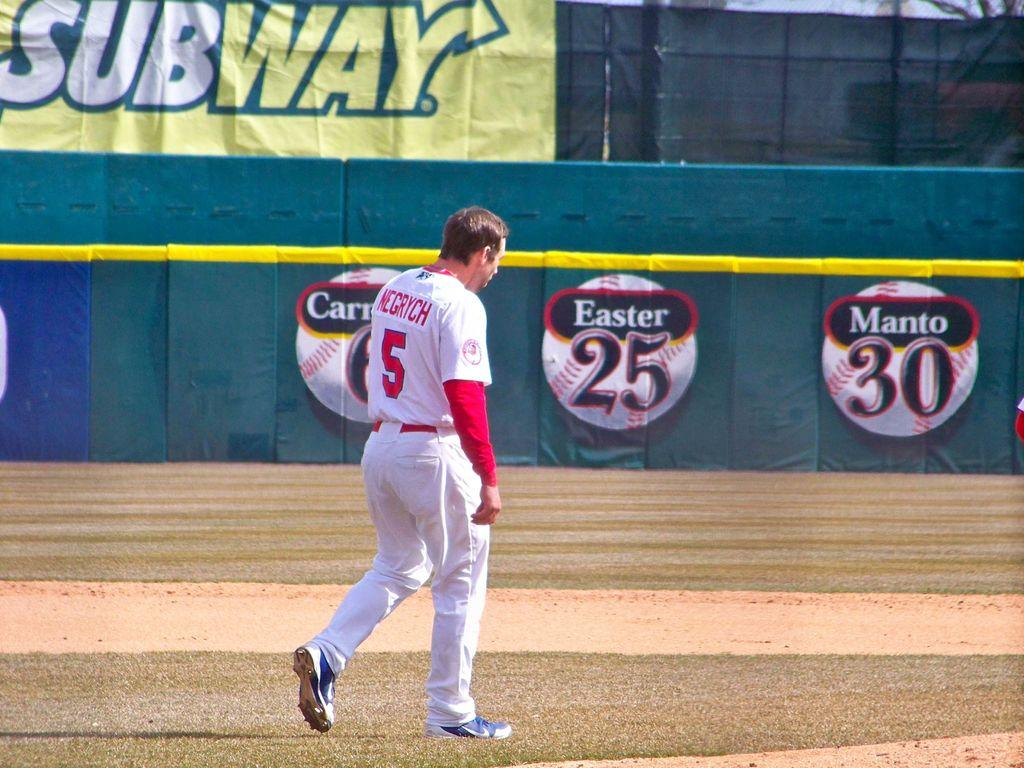<image>
Describe the image concisely. Subway has a banner along the fence of the baseball field. 